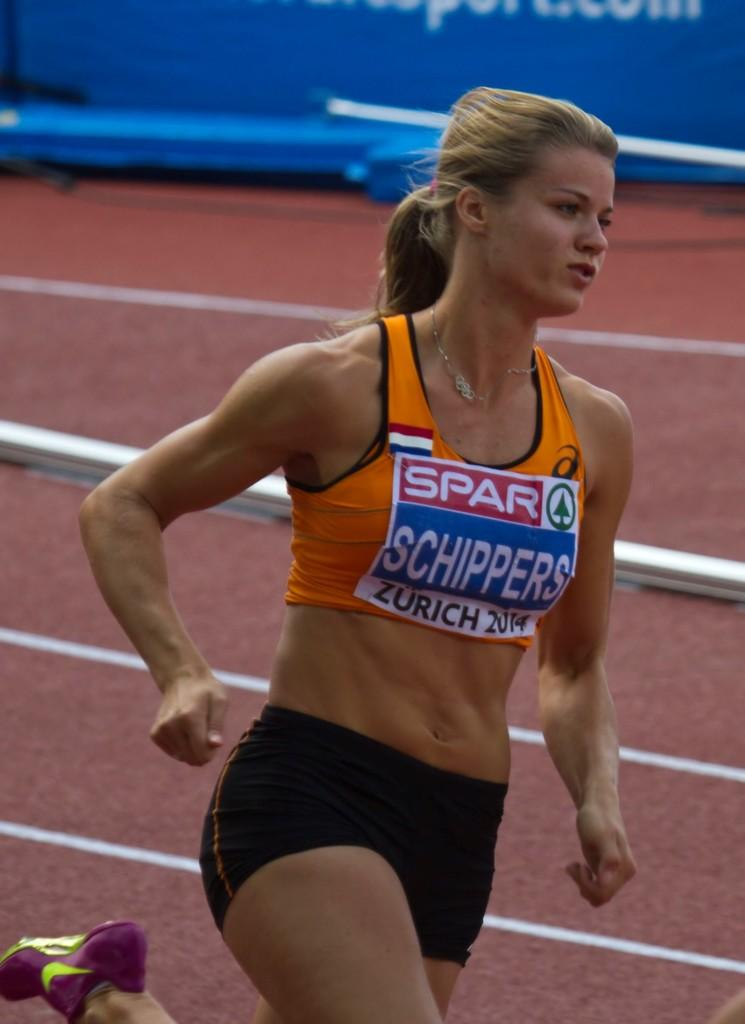<image>
Share a concise interpretation of the image provided. A woman running with a sign on her shirt saying Schippers 